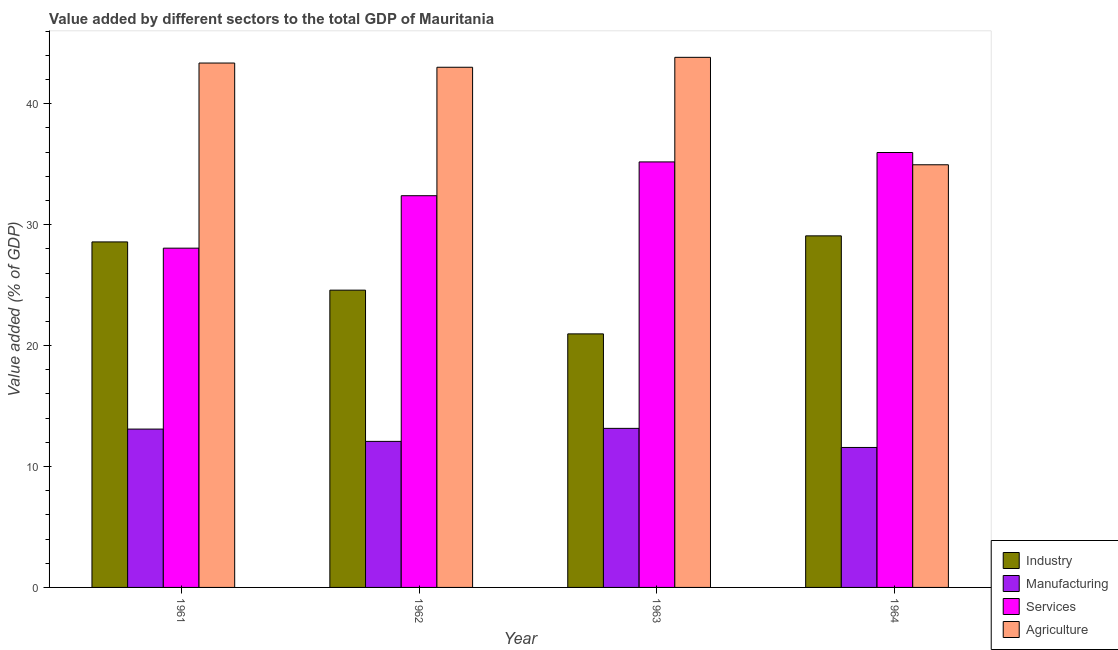How many different coloured bars are there?
Ensure brevity in your answer.  4. How many groups of bars are there?
Ensure brevity in your answer.  4. Are the number of bars per tick equal to the number of legend labels?
Your answer should be compact. Yes. Are the number of bars on each tick of the X-axis equal?
Offer a very short reply. Yes. How many bars are there on the 4th tick from the right?
Ensure brevity in your answer.  4. In how many cases, is the number of bars for a given year not equal to the number of legend labels?
Offer a terse response. 0. What is the value added by industrial sector in 1961?
Provide a succinct answer. 28.57. Across all years, what is the maximum value added by industrial sector?
Your response must be concise. 29.08. Across all years, what is the minimum value added by industrial sector?
Your answer should be very brief. 20.97. In which year was the value added by manufacturing sector minimum?
Your answer should be compact. 1964. What is the total value added by agricultural sector in the graph?
Your answer should be very brief. 165.18. What is the difference between the value added by industrial sector in 1961 and that in 1962?
Ensure brevity in your answer.  3.99. What is the difference between the value added by services sector in 1962 and the value added by manufacturing sector in 1961?
Provide a short and direct response. 4.34. What is the average value added by agricultural sector per year?
Keep it short and to the point. 41.3. In how many years, is the value added by manufacturing sector greater than 32 %?
Offer a terse response. 0. What is the ratio of the value added by manufacturing sector in 1962 to that in 1964?
Keep it short and to the point. 1.04. Is the value added by services sector in 1962 less than that in 1964?
Make the answer very short. Yes. What is the difference between the highest and the second highest value added by agricultural sector?
Offer a very short reply. 0.47. What is the difference between the highest and the lowest value added by industrial sector?
Provide a short and direct response. 8.11. Is the sum of the value added by industrial sector in 1961 and 1962 greater than the maximum value added by agricultural sector across all years?
Keep it short and to the point. Yes. Is it the case that in every year, the sum of the value added by industrial sector and value added by manufacturing sector is greater than the sum of value added by agricultural sector and value added by services sector?
Give a very brief answer. No. What does the 2nd bar from the left in 1963 represents?
Give a very brief answer. Manufacturing. What does the 2nd bar from the right in 1963 represents?
Give a very brief answer. Services. How many bars are there?
Give a very brief answer. 16. Are all the bars in the graph horizontal?
Offer a very short reply. No. Are the values on the major ticks of Y-axis written in scientific E-notation?
Provide a short and direct response. No. Does the graph contain any zero values?
Give a very brief answer. No. How many legend labels are there?
Keep it short and to the point. 4. What is the title of the graph?
Provide a short and direct response. Value added by different sectors to the total GDP of Mauritania. Does "Agriculture" appear as one of the legend labels in the graph?
Your answer should be very brief. Yes. What is the label or title of the X-axis?
Ensure brevity in your answer.  Year. What is the label or title of the Y-axis?
Keep it short and to the point. Value added (% of GDP). What is the Value added (% of GDP) of Industry in 1961?
Your response must be concise. 28.57. What is the Value added (% of GDP) of Manufacturing in 1961?
Keep it short and to the point. 13.09. What is the Value added (% of GDP) in Services in 1961?
Make the answer very short. 28.06. What is the Value added (% of GDP) in Agriculture in 1961?
Give a very brief answer. 43.37. What is the Value added (% of GDP) of Industry in 1962?
Make the answer very short. 24.59. What is the Value added (% of GDP) of Manufacturing in 1962?
Provide a short and direct response. 12.08. What is the Value added (% of GDP) in Services in 1962?
Keep it short and to the point. 32.4. What is the Value added (% of GDP) in Agriculture in 1962?
Offer a very short reply. 43.02. What is the Value added (% of GDP) of Industry in 1963?
Your response must be concise. 20.97. What is the Value added (% of GDP) of Manufacturing in 1963?
Give a very brief answer. 13.15. What is the Value added (% of GDP) in Services in 1963?
Offer a very short reply. 35.19. What is the Value added (% of GDP) in Agriculture in 1963?
Your answer should be compact. 43.84. What is the Value added (% of GDP) of Industry in 1964?
Keep it short and to the point. 29.08. What is the Value added (% of GDP) in Manufacturing in 1964?
Your response must be concise. 11.58. What is the Value added (% of GDP) of Services in 1964?
Give a very brief answer. 35.97. What is the Value added (% of GDP) of Agriculture in 1964?
Provide a short and direct response. 34.95. Across all years, what is the maximum Value added (% of GDP) of Industry?
Your response must be concise. 29.08. Across all years, what is the maximum Value added (% of GDP) of Manufacturing?
Make the answer very short. 13.15. Across all years, what is the maximum Value added (% of GDP) of Services?
Offer a very short reply. 35.97. Across all years, what is the maximum Value added (% of GDP) in Agriculture?
Ensure brevity in your answer.  43.84. Across all years, what is the minimum Value added (% of GDP) of Industry?
Offer a very short reply. 20.97. Across all years, what is the minimum Value added (% of GDP) of Manufacturing?
Your response must be concise. 11.58. Across all years, what is the minimum Value added (% of GDP) in Services?
Your answer should be compact. 28.06. Across all years, what is the minimum Value added (% of GDP) of Agriculture?
Make the answer very short. 34.95. What is the total Value added (% of GDP) in Industry in the graph?
Give a very brief answer. 103.2. What is the total Value added (% of GDP) of Manufacturing in the graph?
Make the answer very short. 49.9. What is the total Value added (% of GDP) of Services in the graph?
Provide a succinct answer. 131.61. What is the total Value added (% of GDP) of Agriculture in the graph?
Give a very brief answer. 165.18. What is the difference between the Value added (% of GDP) in Industry in 1961 and that in 1962?
Ensure brevity in your answer.  3.99. What is the difference between the Value added (% of GDP) in Manufacturing in 1961 and that in 1962?
Make the answer very short. 1.02. What is the difference between the Value added (% of GDP) in Services in 1961 and that in 1962?
Offer a terse response. -4.34. What is the difference between the Value added (% of GDP) in Agriculture in 1961 and that in 1962?
Provide a succinct answer. 0.35. What is the difference between the Value added (% of GDP) of Industry in 1961 and that in 1963?
Provide a succinct answer. 7.6. What is the difference between the Value added (% of GDP) of Manufacturing in 1961 and that in 1963?
Keep it short and to the point. -0.06. What is the difference between the Value added (% of GDP) in Services in 1961 and that in 1963?
Keep it short and to the point. -7.13. What is the difference between the Value added (% of GDP) in Agriculture in 1961 and that in 1963?
Keep it short and to the point. -0.47. What is the difference between the Value added (% of GDP) of Industry in 1961 and that in 1964?
Make the answer very short. -0.5. What is the difference between the Value added (% of GDP) of Manufacturing in 1961 and that in 1964?
Provide a succinct answer. 1.52. What is the difference between the Value added (% of GDP) in Services in 1961 and that in 1964?
Make the answer very short. -7.91. What is the difference between the Value added (% of GDP) of Agriculture in 1961 and that in 1964?
Keep it short and to the point. 8.41. What is the difference between the Value added (% of GDP) of Industry in 1962 and that in 1963?
Give a very brief answer. 3.62. What is the difference between the Value added (% of GDP) of Manufacturing in 1962 and that in 1963?
Give a very brief answer. -1.08. What is the difference between the Value added (% of GDP) in Services in 1962 and that in 1963?
Your response must be concise. -2.79. What is the difference between the Value added (% of GDP) in Agriculture in 1962 and that in 1963?
Keep it short and to the point. -0.82. What is the difference between the Value added (% of GDP) in Industry in 1962 and that in 1964?
Ensure brevity in your answer.  -4.49. What is the difference between the Value added (% of GDP) of Manufacturing in 1962 and that in 1964?
Offer a very short reply. 0.5. What is the difference between the Value added (% of GDP) of Services in 1962 and that in 1964?
Offer a terse response. -3.57. What is the difference between the Value added (% of GDP) of Agriculture in 1962 and that in 1964?
Keep it short and to the point. 8.06. What is the difference between the Value added (% of GDP) of Industry in 1963 and that in 1964?
Your answer should be very brief. -8.11. What is the difference between the Value added (% of GDP) of Manufacturing in 1963 and that in 1964?
Your answer should be very brief. 1.58. What is the difference between the Value added (% of GDP) in Services in 1963 and that in 1964?
Your answer should be compact. -0.78. What is the difference between the Value added (% of GDP) of Agriculture in 1963 and that in 1964?
Offer a very short reply. 8.89. What is the difference between the Value added (% of GDP) in Industry in 1961 and the Value added (% of GDP) in Manufacturing in 1962?
Your answer should be compact. 16.5. What is the difference between the Value added (% of GDP) of Industry in 1961 and the Value added (% of GDP) of Services in 1962?
Your response must be concise. -3.82. What is the difference between the Value added (% of GDP) in Industry in 1961 and the Value added (% of GDP) in Agriculture in 1962?
Provide a short and direct response. -14.44. What is the difference between the Value added (% of GDP) of Manufacturing in 1961 and the Value added (% of GDP) of Services in 1962?
Make the answer very short. -19.3. What is the difference between the Value added (% of GDP) of Manufacturing in 1961 and the Value added (% of GDP) of Agriculture in 1962?
Your answer should be very brief. -29.92. What is the difference between the Value added (% of GDP) in Services in 1961 and the Value added (% of GDP) in Agriculture in 1962?
Offer a very short reply. -14.96. What is the difference between the Value added (% of GDP) of Industry in 1961 and the Value added (% of GDP) of Manufacturing in 1963?
Your response must be concise. 15.42. What is the difference between the Value added (% of GDP) of Industry in 1961 and the Value added (% of GDP) of Services in 1963?
Offer a terse response. -6.62. What is the difference between the Value added (% of GDP) of Industry in 1961 and the Value added (% of GDP) of Agriculture in 1963?
Give a very brief answer. -15.27. What is the difference between the Value added (% of GDP) in Manufacturing in 1961 and the Value added (% of GDP) in Services in 1963?
Your answer should be very brief. -22.1. What is the difference between the Value added (% of GDP) in Manufacturing in 1961 and the Value added (% of GDP) in Agriculture in 1963?
Give a very brief answer. -30.75. What is the difference between the Value added (% of GDP) in Services in 1961 and the Value added (% of GDP) in Agriculture in 1963?
Provide a short and direct response. -15.78. What is the difference between the Value added (% of GDP) in Industry in 1961 and the Value added (% of GDP) in Manufacturing in 1964?
Your answer should be compact. 17. What is the difference between the Value added (% of GDP) of Industry in 1961 and the Value added (% of GDP) of Services in 1964?
Your response must be concise. -7.4. What is the difference between the Value added (% of GDP) in Industry in 1961 and the Value added (% of GDP) in Agriculture in 1964?
Offer a terse response. -6.38. What is the difference between the Value added (% of GDP) in Manufacturing in 1961 and the Value added (% of GDP) in Services in 1964?
Offer a terse response. -22.87. What is the difference between the Value added (% of GDP) in Manufacturing in 1961 and the Value added (% of GDP) in Agriculture in 1964?
Your answer should be very brief. -21.86. What is the difference between the Value added (% of GDP) of Services in 1961 and the Value added (% of GDP) of Agriculture in 1964?
Keep it short and to the point. -6.9. What is the difference between the Value added (% of GDP) of Industry in 1962 and the Value added (% of GDP) of Manufacturing in 1963?
Offer a very short reply. 11.43. What is the difference between the Value added (% of GDP) in Industry in 1962 and the Value added (% of GDP) in Services in 1963?
Provide a short and direct response. -10.61. What is the difference between the Value added (% of GDP) of Industry in 1962 and the Value added (% of GDP) of Agriculture in 1963?
Make the answer very short. -19.25. What is the difference between the Value added (% of GDP) of Manufacturing in 1962 and the Value added (% of GDP) of Services in 1963?
Provide a short and direct response. -23.11. What is the difference between the Value added (% of GDP) in Manufacturing in 1962 and the Value added (% of GDP) in Agriculture in 1963?
Your answer should be compact. -31.76. What is the difference between the Value added (% of GDP) in Services in 1962 and the Value added (% of GDP) in Agriculture in 1963?
Keep it short and to the point. -11.44. What is the difference between the Value added (% of GDP) of Industry in 1962 and the Value added (% of GDP) of Manufacturing in 1964?
Give a very brief answer. 13.01. What is the difference between the Value added (% of GDP) of Industry in 1962 and the Value added (% of GDP) of Services in 1964?
Offer a terse response. -11.38. What is the difference between the Value added (% of GDP) in Industry in 1962 and the Value added (% of GDP) in Agriculture in 1964?
Your answer should be compact. -10.37. What is the difference between the Value added (% of GDP) of Manufacturing in 1962 and the Value added (% of GDP) of Services in 1964?
Offer a very short reply. -23.89. What is the difference between the Value added (% of GDP) in Manufacturing in 1962 and the Value added (% of GDP) in Agriculture in 1964?
Ensure brevity in your answer.  -22.88. What is the difference between the Value added (% of GDP) of Services in 1962 and the Value added (% of GDP) of Agriculture in 1964?
Your answer should be very brief. -2.56. What is the difference between the Value added (% of GDP) of Industry in 1963 and the Value added (% of GDP) of Manufacturing in 1964?
Your response must be concise. 9.39. What is the difference between the Value added (% of GDP) in Industry in 1963 and the Value added (% of GDP) in Services in 1964?
Make the answer very short. -15. What is the difference between the Value added (% of GDP) in Industry in 1963 and the Value added (% of GDP) in Agriculture in 1964?
Keep it short and to the point. -13.99. What is the difference between the Value added (% of GDP) of Manufacturing in 1963 and the Value added (% of GDP) of Services in 1964?
Provide a succinct answer. -22.81. What is the difference between the Value added (% of GDP) in Manufacturing in 1963 and the Value added (% of GDP) in Agriculture in 1964?
Ensure brevity in your answer.  -21.8. What is the difference between the Value added (% of GDP) of Services in 1963 and the Value added (% of GDP) of Agriculture in 1964?
Offer a terse response. 0.24. What is the average Value added (% of GDP) of Industry per year?
Ensure brevity in your answer.  25.8. What is the average Value added (% of GDP) of Manufacturing per year?
Make the answer very short. 12.48. What is the average Value added (% of GDP) in Services per year?
Offer a very short reply. 32.9. What is the average Value added (% of GDP) in Agriculture per year?
Provide a succinct answer. 41.3. In the year 1961, what is the difference between the Value added (% of GDP) in Industry and Value added (% of GDP) in Manufacturing?
Offer a very short reply. 15.48. In the year 1961, what is the difference between the Value added (% of GDP) of Industry and Value added (% of GDP) of Services?
Give a very brief answer. 0.52. In the year 1961, what is the difference between the Value added (% of GDP) in Industry and Value added (% of GDP) in Agriculture?
Offer a very short reply. -14.79. In the year 1961, what is the difference between the Value added (% of GDP) in Manufacturing and Value added (% of GDP) in Services?
Make the answer very short. -14.96. In the year 1961, what is the difference between the Value added (% of GDP) of Manufacturing and Value added (% of GDP) of Agriculture?
Make the answer very short. -30.27. In the year 1961, what is the difference between the Value added (% of GDP) of Services and Value added (% of GDP) of Agriculture?
Your answer should be compact. -15.31. In the year 1962, what is the difference between the Value added (% of GDP) in Industry and Value added (% of GDP) in Manufacturing?
Provide a short and direct response. 12.51. In the year 1962, what is the difference between the Value added (% of GDP) in Industry and Value added (% of GDP) in Services?
Make the answer very short. -7.81. In the year 1962, what is the difference between the Value added (% of GDP) of Industry and Value added (% of GDP) of Agriculture?
Your response must be concise. -18.43. In the year 1962, what is the difference between the Value added (% of GDP) of Manufacturing and Value added (% of GDP) of Services?
Your answer should be compact. -20.32. In the year 1962, what is the difference between the Value added (% of GDP) of Manufacturing and Value added (% of GDP) of Agriculture?
Make the answer very short. -30.94. In the year 1962, what is the difference between the Value added (% of GDP) of Services and Value added (% of GDP) of Agriculture?
Your response must be concise. -10.62. In the year 1963, what is the difference between the Value added (% of GDP) in Industry and Value added (% of GDP) in Manufacturing?
Offer a terse response. 7.81. In the year 1963, what is the difference between the Value added (% of GDP) in Industry and Value added (% of GDP) in Services?
Offer a terse response. -14.22. In the year 1963, what is the difference between the Value added (% of GDP) in Industry and Value added (% of GDP) in Agriculture?
Provide a succinct answer. -22.87. In the year 1963, what is the difference between the Value added (% of GDP) of Manufacturing and Value added (% of GDP) of Services?
Offer a terse response. -22.04. In the year 1963, what is the difference between the Value added (% of GDP) in Manufacturing and Value added (% of GDP) in Agriculture?
Your answer should be compact. -30.69. In the year 1963, what is the difference between the Value added (% of GDP) in Services and Value added (% of GDP) in Agriculture?
Ensure brevity in your answer.  -8.65. In the year 1964, what is the difference between the Value added (% of GDP) in Industry and Value added (% of GDP) in Manufacturing?
Provide a short and direct response. 17.5. In the year 1964, what is the difference between the Value added (% of GDP) in Industry and Value added (% of GDP) in Services?
Ensure brevity in your answer.  -6.89. In the year 1964, what is the difference between the Value added (% of GDP) in Industry and Value added (% of GDP) in Agriculture?
Provide a succinct answer. -5.88. In the year 1964, what is the difference between the Value added (% of GDP) in Manufacturing and Value added (% of GDP) in Services?
Your answer should be very brief. -24.39. In the year 1964, what is the difference between the Value added (% of GDP) of Manufacturing and Value added (% of GDP) of Agriculture?
Your response must be concise. -23.38. In the year 1964, what is the difference between the Value added (% of GDP) in Services and Value added (% of GDP) in Agriculture?
Make the answer very short. 1.01. What is the ratio of the Value added (% of GDP) in Industry in 1961 to that in 1962?
Ensure brevity in your answer.  1.16. What is the ratio of the Value added (% of GDP) of Manufacturing in 1961 to that in 1962?
Offer a very short reply. 1.08. What is the ratio of the Value added (% of GDP) in Services in 1961 to that in 1962?
Ensure brevity in your answer.  0.87. What is the ratio of the Value added (% of GDP) in Industry in 1961 to that in 1963?
Offer a terse response. 1.36. What is the ratio of the Value added (% of GDP) in Services in 1961 to that in 1963?
Make the answer very short. 0.8. What is the ratio of the Value added (% of GDP) in Agriculture in 1961 to that in 1963?
Provide a short and direct response. 0.99. What is the ratio of the Value added (% of GDP) of Industry in 1961 to that in 1964?
Keep it short and to the point. 0.98. What is the ratio of the Value added (% of GDP) in Manufacturing in 1961 to that in 1964?
Keep it short and to the point. 1.13. What is the ratio of the Value added (% of GDP) of Services in 1961 to that in 1964?
Make the answer very short. 0.78. What is the ratio of the Value added (% of GDP) in Agriculture in 1961 to that in 1964?
Offer a very short reply. 1.24. What is the ratio of the Value added (% of GDP) of Industry in 1962 to that in 1963?
Ensure brevity in your answer.  1.17. What is the ratio of the Value added (% of GDP) in Manufacturing in 1962 to that in 1963?
Provide a succinct answer. 0.92. What is the ratio of the Value added (% of GDP) of Services in 1962 to that in 1963?
Offer a terse response. 0.92. What is the ratio of the Value added (% of GDP) in Agriculture in 1962 to that in 1963?
Make the answer very short. 0.98. What is the ratio of the Value added (% of GDP) of Industry in 1962 to that in 1964?
Ensure brevity in your answer.  0.85. What is the ratio of the Value added (% of GDP) in Manufacturing in 1962 to that in 1964?
Provide a succinct answer. 1.04. What is the ratio of the Value added (% of GDP) of Services in 1962 to that in 1964?
Give a very brief answer. 0.9. What is the ratio of the Value added (% of GDP) in Agriculture in 1962 to that in 1964?
Your response must be concise. 1.23. What is the ratio of the Value added (% of GDP) of Industry in 1963 to that in 1964?
Offer a very short reply. 0.72. What is the ratio of the Value added (% of GDP) of Manufacturing in 1963 to that in 1964?
Make the answer very short. 1.14. What is the ratio of the Value added (% of GDP) of Services in 1963 to that in 1964?
Make the answer very short. 0.98. What is the ratio of the Value added (% of GDP) of Agriculture in 1963 to that in 1964?
Provide a short and direct response. 1.25. What is the difference between the highest and the second highest Value added (% of GDP) of Industry?
Make the answer very short. 0.5. What is the difference between the highest and the second highest Value added (% of GDP) of Manufacturing?
Ensure brevity in your answer.  0.06. What is the difference between the highest and the second highest Value added (% of GDP) in Services?
Provide a succinct answer. 0.78. What is the difference between the highest and the second highest Value added (% of GDP) of Agriculture?
Offer a terse response. 0.47. What is the difference between the highest and the lowest Value added (% of GDP) of Industry?
Your response must be concise. 8.11. What is the difference between the highest and the lowest Value added (% of GDP) of Manufacturing?
Give a very brief answer. 1.58. What is the difference between the highest and the lowest Value added (% of GDP) of Services?
Make the answer very short. 7.91. What is the difference between the highest and the lowest Value added (% of GDP) of Agriculture?
Give a very brief answer. 8.89. 